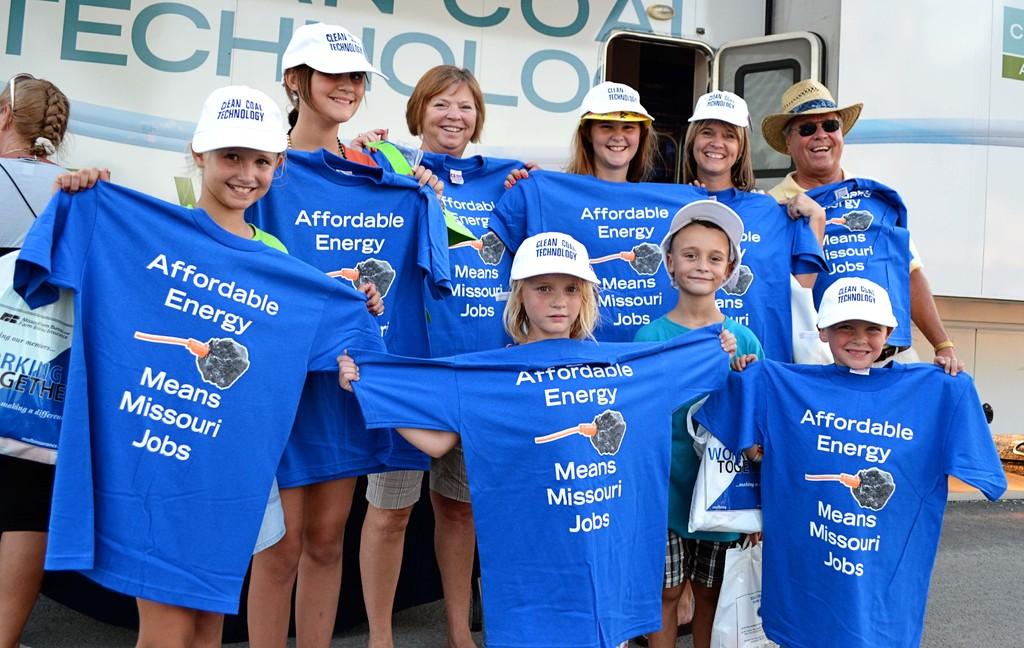What message do these people believe in?
Ensure brevity in your answer.  Affordable energy means missouri jobs. What does the white hats say?
Offer a terse response. Clean coal technology. 